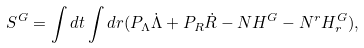<formula> <loc_0><loc_0><loc_500><loc_500>S ^ { G } = \int d t \int d r ( P _ { \Lambda } \dot { \Lambda } + P _ { R } \dot { R } - N H ^ { G } - N ^ { r } H _ { r } ^ { G } ) ,</formula> 